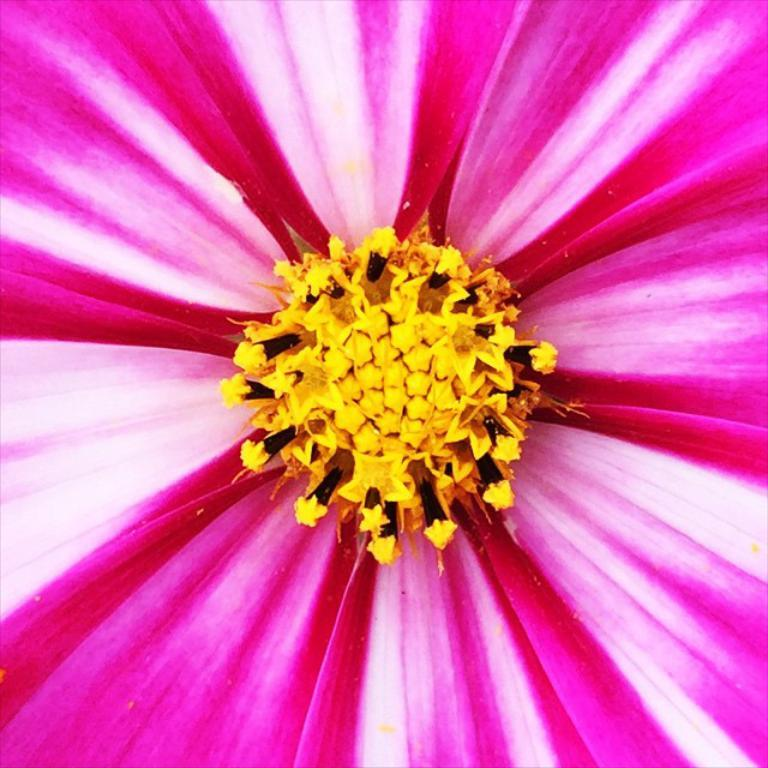What is the main subject of the image? The main subject of the image is a flower. Can you describe the flower in the image? The image contains a close picture of a flower, so it is difficult to see the entire flower, but we can observe its details. How many units of the blade are visible in the image? There is no blade present in the image; it features a close picture of a flower. 